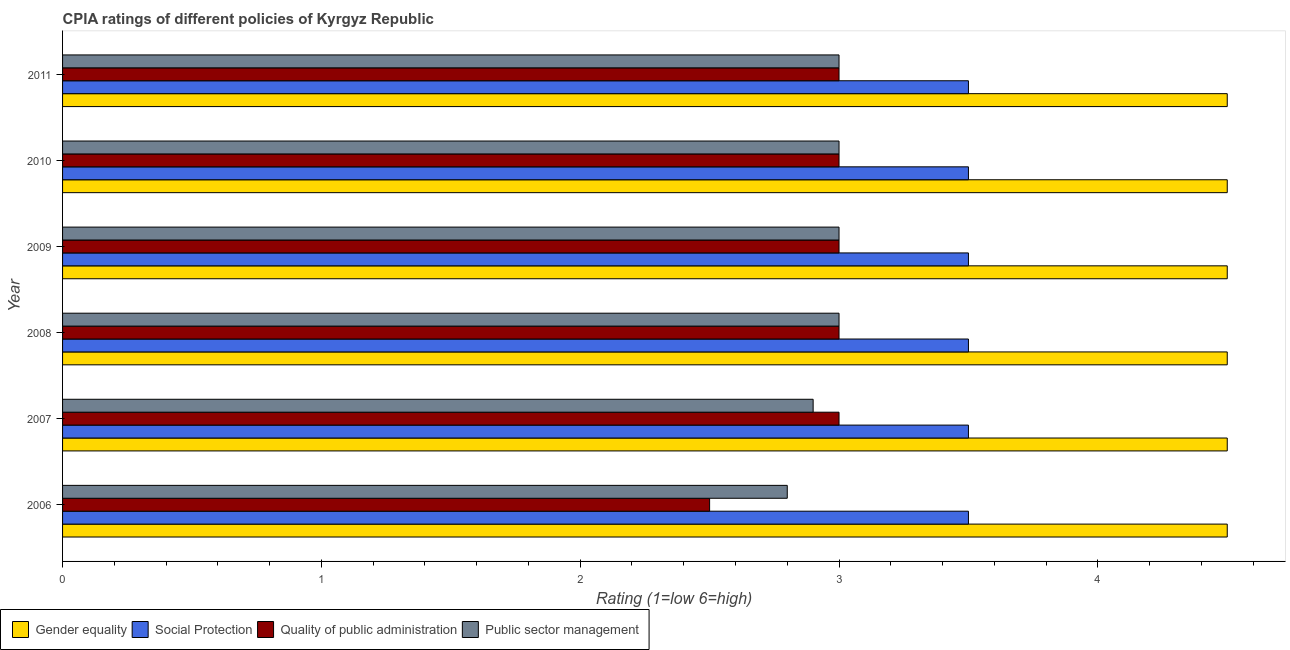How many different coloured bars are there?
Give a very brief answer. 4. How many groups of bars are there?
Offer a terse response. 6. Are the number of bars per tick equal to the number of legend labels?
Offer a very short reply. Yes. How many bars are there on the 4th tick from the top?
Ensure brevity in your answer.  4. What is the cpia rating of social protection in 2009?
Your answer should be very brief. 3.5. Across all years, what is the maximum cpia rating of social protection?
Your answer should be compact. 3.5. Across all years, what is the minimum cpia rating of social protection?
Ensure brevity in your answer.  3.5. In which year was the cpia rating of quality of public administration minimum?
Your answer should be very brief. 2006. What is the difference between the cpia rating of quality of public administration in 2007 and that in 2009?
Provide a succinct answer. 0. Is the cpia rating of public sector management in 2007 less than that in 2008?
Give a very brief answer. Yes. Is the difference between the cpia rating of social protection in 2008 and 2009 greater than the difference between the cpia rating of gender equality in 2008 and 2009?
Your answer should be very brief. No. What is the difference between the highest and the lowest cpia rating of gender equality?
Ensure brevity in your answer.  0. What does the 4th bar from the top in 2006 represents?
Ensure brevity in your answer.  Gender equality. What does the 1st bar from the bottom in 2010 represents?
Offer a terse response. Gender equality. Is it the case that in every year, the sum of the cpia rating of gender equality and cpia rating of social protection is greater than the cpia rating of quality of public administration?
Your answer should be very brief. Yes. Are all the bars in the graph horizontal?
Your response must be concise. Yes. Are the values on the major ticks of X-axis written in scientific E-notation?
Offer a very short reply. No. Does the graph contain any zero values?
Your response must be concise. No. How are the legend labels stacked?
Provide a succinct answer. Horizontal. What is the title of the graph?
Offer a very short reply. CPIA ratings of different policies of Kyrgyz Republic. What is the Rating (1=low 6=high) in Public sector management in 2006?
Your answer should be very brief. 2.8. What is the Rating (1=low 6=high) of Gender equality in 2007?
Provide a succinct answer. 4.5. What is the Rating (1=low 6=high) in Social Protection in 2007?
Ensure brevity in your answer.  3.5. What is the Rating (1=low 6=high) in Quality of public administration in 2007?
Ensure brevity in your answer.  3. What is the Rating (1=low 6=high) of Public sector management in 2007?
Offer a very short reply. 2.9. What is the Rating (1=low 6=high) in Quality of public administration in 2008?
Give a very brief answer. 3. What is the Rating (1=low 6=high) of Public sector management in 2008?
Give a very brief answer. 3. What is the Rating (1=low 6=high) in Gender equality in 2009?
Provide a succinct answer. 4.5. What is the Rating (1=low 6=high) of Quality of public administration in 2009?
Keep it short and to the point. 3. What is the Rating (1=low 6=high) of Public sector management in 2009?
Give a very brief answer. 3. What is the Rating (1=low 6=high) of Gender equality in 2011?
Your answer should be compact. 4.5. What is the Rating (1=low 6=high) of Quality of public administration in 2011?
Offer a terse response. 3. What is the Rating (1=low 6=high) in Public sector management in 2011?
Provide a short and direct response. 3. Across all years, what is the maximum Rating (1=low 6=high) in Gender equality?
Provide a succinct answer. 4.5. Across all years, what is the maximum Rating (1=low 6=high) in Social Protection?
Your answer should be compact. 3.5. Across all years, what is the maximum Rating (1=low 6=high) in Quality of public administration?
Your answer should be very brief. 3. Across all years, what is the minimum Rating (1=low 6=high) in Gender equality?
Provide a succinct answer. 4.5. Across all years, what is the minimum Rating (1=low 6=high) of Social Protection?
Provide a short and direct response. 3.5. Across all years, what is the minimum Rating (1=low 6=high) in Quality of public administration?
Your response must be concise. 2.5. What is the total Rating (1=low 6=high) in Gender equality in the graph?
Your answer should be very brief. 27. What is the total Rating (1=low 6=high) in Social Protection in the graph?
Keep it short and to the point. 21. What is the total Rating (1=low 6=high) of Public sector management in the graph?
Ensure brevity in your answer.  17.7. What is the difference between the Rating (1=low 6=high) of Quality of public administration in 2006 and that in 2007?
Make the answer very short. -0.5. What is the difference between the Rating (1=low 6=high) of Gender equality in 2006 and that in 2008?
Provide a succinct answer. 0. What is the difference between the Rating (1=low 6=high) of Quality of public administration in 2006 and that in 2008?
Make the answer very short. -0.5. What is the difference between the Rating (1=low 6=high) in Public sector management in 2006 and that in 2008?
Give a very brief answer. -0.2. What is the difference between the Rating (1=low 6=high) in Gender equality in 2006 and that in 2009?
Provide a succinct answer. 0. What is the difference between the Rating (1=low 6=high) of Social Protection in 2006 and that in 2009?
Offer a terse response. 0. What is the difference between the Rating (1=low 6=high) in Quality of public administration in 2006 and that in 2009?
Offer a terse response. -0.5. What is the difference between the Rating (1=low 6=high) of Gender equality in 2006 and that in 2010?
Offer a very short reply. 0. What is the difference between the Rating (1=low 6=high) of Social Protection in 2006 and that in 2010?
Ensure brevity in your answer.  0. What is the difference between the Rating (1=low 6=high) of Gender equality in 2006 and that in 2011?
Keep it short and to the point. 0. What is the difference between the Rating (1=low 6=high) in Social Protection in 2006 and that in 2011?
Make the answer very short. 0. What is the difference between the Rating (1=low 6=high) in Quality of public administration in 2006 and that in 2011?
Ensure brevity in your answer.  -0.5. What is the difference between the Rating (1=low 6=high) of Public sector management in 2006 and that in 2011?
Your answer should be very brief. -0.2. What is the difference between the Rating (1=low 6=high) of Gender equality in 2007 and that in 2008?
Your answer should be very brief. 0. What is the difference between the Rating (1=low 6=high) of Social Protection in 2007 and that in 2008?
Give a very brief answer. 0. What is the difference between the Rating (1=low 6=high) of Quality of public administration in 2007 and that in 2008?
Ensure brevity in your answer.  0. What is the difference between the Rating (1=low 6=high) of Gender equality in 2007 and that in 2009?
Provide a succinct answer. 0. What is the difference between the Rating (1=low 6=high) of Social Protection in 2007 and that in 2009?
Offer a terse response. 0. What is the difference between the Rating (1=low 6=high) of Quality of public administration in 2007 and that in 2009?
Provide a succinct answer. 0. What is the difference between the Rating (1=low 6=high) in Public sector management in 2007 and that in 2009?
Keep it short and to the point. -0.1. What is the difference between the Rating (1=low 6=high) in Social Protection in 2007 and that in 2010?
Your response must be concise. 0. What is the difference between the Rating (1=low 6=high) in Quality of public administration in 2007 and that in 2010?
Ensure brevity in your answer.  0. What is the difference between the Rating (1=low 6=high) in Public sector management in 2007 and that in 2010?
Provide a short and direct response. -0.1. What is the difference between the Rating (1=low 6=high) in Quality of public administration in 2007 and that in 2011?
Your answer should be compact. 0. What is the difference between the Rating (1=low 6=high) of Social Protection in 2008 and that in 2009?
Your answer should be very brief. 0. What is the difference between the Rating (1=low 6=high) in Public sector management in 2008 and that in 2009?
Give a very brief answer. 0. What is the difference between the Rating (1=low 6=high) of Quality of public administration in 2008 and that in 2010?
Provide a succinct answer. 0. What is the difference between the Rating (1=low 6=high) of Public sector management in 2008 and that in 2010?
Keep it short and to the point. 0. What is the difference between the Rating (1=low 6=high) of Gender equality in 2008 and that in 2011?
Make the answer very short. 0. What is the difference between the Rating (1=low 6=high) in Public sector management in 2008 and that in 2011?
Provide a short and direct response. 0. What is the difference between the Rating (1=low 6=high) in Gender equality in 2009 and that in 2010?
Give a very brief answer. 0. What is the difference between the Rating (1=low 6=high) in Public sector management in 2009 and that in 2010?
Give a very brief answer. 0. What is the difference between the Rating (1=low 6=high) of Quality of public administration in 2009 and that in 2011?
Provide a succinct answer. 0. What is the difference between the Rating (1=low 6=high) of Gender equality in 2010 and that in 2011?
Keep it short and to the point. 0. What is the difference between the Rating (1=low 6=high) of Social Protection in 2010 and that in 2011?
Offer a very short reply. 0. What is the difference between the Rating (1=low 6=high) in Public sector management in 2010 and that in 2011?
Ensure brevity in your answer.  0. What is the difference between the Rating (1=low 6=high) in Gender equality in 2006 and the Rating (1=low 6=high) in Social Protection in 2007?
Ensure brevity in your answer.  1. What is the difference between the Rating (1=low 6=high) of Social Protection in 2006 and the Rating (1=low 6=high) of Public sector management in 2007?
Give a very brief answer. 0.6. What is the difference between the Rating (1=low 6=high) of Gender equality in 2006 and the Rating (1=low 6=high) of Social Protection in 2008?
Give a very brief answer. 1. What is the difference between the Rating (1=low 6=high) of Social Protection in 2006 and the Rating (1=low 6=high) of Quality of public administration in 2008?
Your answer should be very brief. 0.5. What is the difference between the Rating (1=low 6=high) of Quality of public administration in 2006 and the Rating (1=low 6=high) of Public sector management in 2008?
Keep it short and to the point. -0.5. What is the difference between the Rating (1=low 6=high) of Gender equality in 2006 and the Rating (1=low 6=high) of Quality of public administration in 2009?
Offer a very short reply. 1.5. What is the difference between the Rating (1=low 6=high) of Gender equality in 2006 and the Rating (1=low 6=high) of Public sector management in 2009?
Your answer should be compact. 1.5. What is the difference between the Rating (1=low 6=high) of Social Protection in 2006 and the Rating (1=low 6=high) of Quality of public administration in 2009?
Provide a short and direct response. 0.5. What is the difference between the Rating (1=low 6=high) in Social Protection in 2006 and the Rating (1=low 6=high) in Public sector management in 2009?
Keep it short and to the point. 0.5. What is the difference between the Rating (1=low 6=high) in Quality of public administration in 2006 and the Rating (1=low 6=high) in Public sector management in 2009?
Ensure brevity in your answer.  -0.5. What is the difference between the Rating (1=low 6=high) of Gender equality in 2006 and the Rating (1=low 6=high) of Social Protection in 2010?
Your response must be concise. 1. What is the difference between the Rating (1=low 6=high) in Gender equality in 2006 and the Rating (1=low 6=high) in Quality of public administration in 2010?
Offer a very short reply. 1.5. What is the difference between the Rating (1=low 6=high) of Gender equality in 2006 and the Rating (1=low 6=high) of Public sector management in 2010?
Your answer should be very brief. 1.5. What is the difference between the Rating (1=low 6=high) of Social Protection in 2006 and the Rating (1=low 6=high) of Quality of public administration in 2010?
Keep it short and to the point. 0.5. What is the difference between the Rating (1=low 6=high) in Gender equality in 2006 and the Rating (1=low 6=high) in Social Protection in 2011?
Your answer should be very brief. 1. What is the difference between the Rating (1=low 6=high) in Quality of public administration in 2006 and the Rating (1=low 6=high) in Public sector management in 2011?
Give a very brief answer. -0.5. What is the difference between the Rating (1=low 6=high) of Gender equality in 2007 and the Rating (1=low 6=high) of Social Protection in 2008?
Your answer should be compact. 1. What is the difference between the Rating (1=low 6=high) in Gender equality in 2007 and the Rating (1=low 6=high) in Quality of public administration in 2008?
Provide a short and direct response. 1.5. What is the difference between the Rating (1=low 6=high) of Gender equality in 2007 and the Rating (1=low 6=high) of Public sector management in 2008?
Give a very brief answer. 1.5. What is the difference between the Rating (1=low 6=high) in Social Protection in 2007 and the Rating (1=low 6=high) in Public sector management in 2008?
Your response must be concise. 0.5. What is the difference between the Rating (1=low 6=high) in Quality of public administration in 2007 and the Rating (1=low 6=high) in Public sector management in 2008?
Make the answer very short. 0. What is the difference between the Rating (1=low 6=high) in Gender equality in 2007 and the Rating (1=low 6=high) in Social Protection in 2009?
Keep it short and to the point. 1. What is the difference between the Rating (1=low 6=high) in Gender equality in 2007 and the Rating (1=low 6=high) in Quality of public administration in 2009?
Give a very brief answer. 1.5. What is the difference between the Rating (1=low 6=high) of Social Protection in 2007 and the Rating (1=low 6=high) of Quality of public administration in 2009?
Give a very brief answer. 0.5. What is the difference between the Rating (1=low 6=high) of Gender equality in 2007 and the Rating (1=low 6=high) of Social Protection in 2010?
Ensure brevity in your answer.  1. What is the difference between the Rating (1=low 6=high) in Gender equality in 2007 and the Rating (1=low 6=high) in Quality of public administration in 2010?
Give a very brief answer. 1.5. What is the difference between the Rating (1=low 6=high) of Gender equality in 2007 and the Rating (1=low 6=high) of Public sector management in 2010?
Your response must be concise. 1.5. What is the difference between the Rating (1=low 6=high) in Social Protection in 2007 and the Rating (1=low 6=high) in Quality of public administration in 2010?
Provide a succinct answer. 0.5. What is the difference between the Rating (1=low 6=high) of Social Protection in 2007 and the Rating (1=low 6=high) of Public sector management in 2010?
Ensure brevity in your answer.  0.5. What is the difference between the Rating (1=low 6=high) in Gender equality in 2007 and the Rating (1=low 6=high) in Public sector management in 2011?
Offer a very short reply. 1.5. What is the difference between the Rating (1=low 6=high) in Social Protection in 2007 and the Rating (1=low 6=high) in Quality of public administration in 2011?
Provide a short and direct response. 0.5. What is the difference between the Rating (1=low 6=high) of Social Protection in 2007 and the Rating (1=low 6=high) of Public sector management in 2011?
Offer a very short reply. 0.5. What is the difference between the Rating (1=low 6=high) of Gender equality in 2008 and the Rating (1=low 6=high) of Social Protection in 2009?
Offer a very short reply. 1. What is the difference between the Rating (1=low 6=high) in Gender equality in 2008 and the Rating (1=low 6=high) in Quality of public administration in 2009?
Provide a short and direct response. 1.5. What is the difference between the Rating (1=low 6=high) of Gender equality in 2008 and the Rating (1=low 6=high) of Quality of public administration in 2010?
Ensure brevity in your answer.  1.5. What is the difference between the Rating (1=low 6=high) in Social Protection in 2008 and the Rating (1=low 6=high) in Quality of public administration in 2011?
Your answer should be compact. 0.5. What is the difference between the Rating (1=low 6=high) in Social Protection in 2008 and the Rating (1=low 6=high) in Public sector management in 2011?
Provide a succinct answer. 0.5. What is the difference between the Rating (1=low 6=high) in Quality of public administration in 2008 and the Rating (1=low 6=high) in Public sector management in 2011?
Offer a very short reply. 0. What is the difference between the Rating (1=low 6=high) in Gender equality in 2009 and the Rating (1=low 6=high) in Social Protection in 2010?
Provide a short and direct response. 1. What is the difference between the Rating (1=low 6=high) in Gender equality in 2009 and the Rating (1=low 6=high) in Public sector management in 2010?
Provide a succinct answer. 1.5. What is the difference between the Rating (1=low 6=high) of Gender equality in 2009 and the Rating (1=low 6=high) of Social Protection in 2011?
Ensure brevity in your answer.  1. What is the difference between the Rating (1=low 6=high) of Gender equality in 2009 and the Rating (1=low 6=high) of Quality of public administration in 2011?
Offer a terse response. 1.5. What is the difference between the Rating (1=low 6=high) of Social Protection in 2009 and the Rating (1=low 6=high) of Quality of public administration in 2011?
Keep it short and to the point. 0.5. What is the difference between the Rating (1=low 6=high) of Gender equality in 2010 and the Rating (1=low 6=high) of Public sector management in 2011?
Make the answer very short. 1.5. What is the difference between the Rating (1=low 6=high) in Social Protection in 2010 and the Rating (1=low 6=high) in Public sector management in 2011?
Provide a succinct answer. 0.5. What is the average Rating (1=low 6=high) of Gender equality per year?
Provide a succinct answer. 4.5. What is the average Rating (1=low 6=high) in Social Protection per year?
Provide a succinct answer. 3.5. What is the average Rating (1=low 6=high) in Quality of public administration per year?
Your answer should be compact. 2.92. What is the average Rating (1=low 6=high) in Public sector management per year?
Make the answer very short. 2.95. In the year 2006, what is the difference between the Rating (1=low 6=high) of Gender equality and Rating (1=low 6=high) of Social Protection?
Offer a terse response. 1. In the year 2006, what is the difference between the Rating (1=low 6=high) of Social Protection and Rating (1=low 6=high) of Quality of public administration?
Offer a very short reply. 1. In the year 2006, what is the difference between the Rating (1=low 6=high) in Social Protection and Rating (1=low 6=high) in Public sector management?
Offer a terse response. 0.7. In the year 2007, what is the difference between the Rating (1=low 6=high) of Gender equality and Rating (1=low 6=high) of Social Protection?
Give a very brief answer. 1. In the year 2007, what is the difference between the Rating (1=low 6=high) in Gender equality and Rating (1=low 6=high) in Quality of public administration?
Offer a very short reply. 1.5. In the year 2007, what is the difference between the Rating (1=low 6=high) in Quality of public administration and Rating (1=low 6=high) in Public sector management?
Give a very brief answer. 0.1. In the year 2008, what is the difference between the Rating (1=low 6=high) in Gender equality and Rating (1=low 6=high) in Quality of public administration?
Offer a terse response. 1.5. In the year 2008, what is the difference between the Rating (1=low 6=high) in Gender equality and Rating (1=low 6=high) in Public sector management?
Provide a succinct answer. 1.5. In the year 2008, what is the difference between the Rating (1=low 6=high) of Quality of public administration and Rating (1=low 6=high) of Public sector management?
Your response must be concise. 0. In the year 2009, what is the difference between the Rating (1=low 6=high) in Gender equality and Rating (1=low 6=high) in Social Protection?
Keep it short and to the point. 1. In the year 2009, what is the difference between the Rating (1=low 6=high) in Social Protection and Rating (1=low 6=high) in Public sector management?
Give a very brief answer. 0.5. In the year 2009, what is the difference between the Rating (1=low 6=high) of Quality of public administration and Rating (1=low 6=high) of Public sector management?
Provide a short and direct response. 0. In the year 2010, what is the difference between the Rating (1=low 6=high) in Gender equality and Rating (1=low 6=high) in Public sector management?
Your response must be concise. 1.5. In the year 2010, what is the difference between the Rating (1=low 6=high) of Social Protection and Rating (1=low 6=high) of Public sector management?
Offer a terse response. 0.5. In the year 2011, what is the difference between the Rating (1=low 6=high) in Gender equality and Rating (1=low 6=high) in Social Protection?
Your answer should be very brief. 1. In the year 2011, what is the difference between the Rating (1=low 6=high) in Gender equality and Rating (1=low 6=high) in Quality of public administration?
Offer a very short reply. 1.5. In the year 2011, what is the difference between the Rating (1=low 6=high) in Social Protection and Rating (1=low 6=high) in Public sector management?
Ensure brevity in your answer.  0.5. What is the ratio of the Rating (1=low 6=high) of Gender equality in 2006 to that in 2007?
Keep it short and to the point. 1. What is the ratio of the Rating (1=low 6=high) in Public sector management in 2006 to that in 2007?
Offer a terse response. 0.97. What is the ratio of the Rating (1=low 6=high) of Gender equality in 2006 to that in 2008?
Keep it short and to the point. 1. What is the ratio of the Rating (1=low 6=high) in Social Protection in 2006 to that in 2009?
Offer a terse response. 1. What is the ratio of the Rating (1=low 6=high) in Quality of public administration in 2006 to that in 2009?
Provide a short and direct response. 0.83. What is the ratio of the Rating (1=low 6=high) in Public sector management in 2006 to that in 2009?
Keep it short and to the point. 0.93. What is the ratio of the Rating (1=low 6=high) of Gender equality in 2006 to that in 2010?
Offer a terse response. 1. What is the ratio of the Rating (1=low 6=high) of Quality of public administration in 2006 to that in 2010?
Keep it short and to the point. 0.83. What is the ratio of the Rating (1=low 6=high) of Public sector management in 2006 to that in 2011?
Offer a very short reply. 0.93. What is the ratio of the Rating (1=low 6=high) in Gender equality in 2007 to that in 2008?
Your response must be concise. 1. What is the ratio of the Rating (1=low 6=high) in Social Protection in 2007 to that in 2008?
Provide a succinct answer. 1. What is the ratio of the Rating (1=low 6=high) in Quality of public administration in 2007 to that in 2008?
Ensure brevity in your answer.  1. What is the ratio of the Rating (1=low 6=high) in Public sector management in 2007 to that in 2008?
Your answer should be very brief. 0.97. What is the ratio of the Rating (1=low 6=high) in Gender equality in 2007 to that in 2009?
Offer a very short reply. 1. What is the ratio of the Rating (1=low 6=high) of Public sector management in 2007 to that in 2009?
Your response must be concise. 0.97. What is the ratio of the Rating (1=low 6=high) in Social Protection in 2007 to that in 2010?
Offer a very short reply. 1. What is the ratio of the Rating (1=low 6=high) of Quality of public administration in 2007 to that in 2010?
Provide a succinct answer. 1. What is the ratio of the Rating (1=low 6=high) in Public sector management in 2007 to that in 2010?
Make the answer very short. 0.97. What is the ratio of the Rating (1=low 6=high) of Gender equality in 2007 to that in 2011?
Make the answer very short. 1. What is the ratio of the Rating (1=low 6=high) in Quality of public administration in 2007 to that in 2011?
Offer a very short reply. 1. What is the ratio of the Rating (1=low 6=high) in Public sector management in 2007 to that in 2011?
Offer a terse response. 0.97. What is the ratio of the Rating (1=low 6=high) in Public sector management in 2008 to that in 2009?
Your response must be concise. 1. What is the ratio of the Rating (1=low 6=high) of Gender equality in 2008 to that in 2010?
Provide a succinct answer. 1. What is the ratio of the Rating (1=low 6=high) of Social Protection in 2008 to that in 2010?
Make the answer very short. 1. What is the ratio of the Rating (1=low 6=high) of Public sector management in 2008 to that in 2010?
Offer a very short reply. 1. What is the ratio of the Rating (1=low 6=high) of Gender equality in 2008 to that in 2011?
Offer a very short reply. 1. What is the ratio of the Rating (1=low 6=high) of Social Protection in 2008 to that in 2011?
Your answer should be compact. 1. What is the ratio of the Rating (1=low 6=high) of Public sector management in 2008 to that in 2011?
Your answer should be compact. 1. What is the ratio of the Rating (1=low 6=high) of Quality of public administration in 2009 to that in 2010?
Offer a very short reply. 1. What is the ratio of the Rating (1=low 6=high) of Gender equality in 2009 to that in 2011?
Offer a terse response. 1. What is the ratio of the Rating (1=low 6=high) in Social Protection in 2009 to that in 2011?
Make the answer very short. 1. What is the ratio of the Rating (1=low 6=high) of Gender equality in 2010 to that in 2011?
Provide a short and direct response. 1. What is the ratio of the Rating (1=low 6=high) in Social Protection in 2010 to that in 2011?
Ensure brevity in your answer.  1. What is the ratio of the Rating (1=low 6=high) of Public sector management in 2010 to that in 2011?
Your answer should be compact. 1. What is the difference between the highest and the lowest Rating (1=low 6=high) of Quality of public administration?
Give a very brief answer. 0.5. What is the difference between the highest and the lowest Rating (1=low 6=high) of Public sector management?
Your response must be concise. 0.2. 